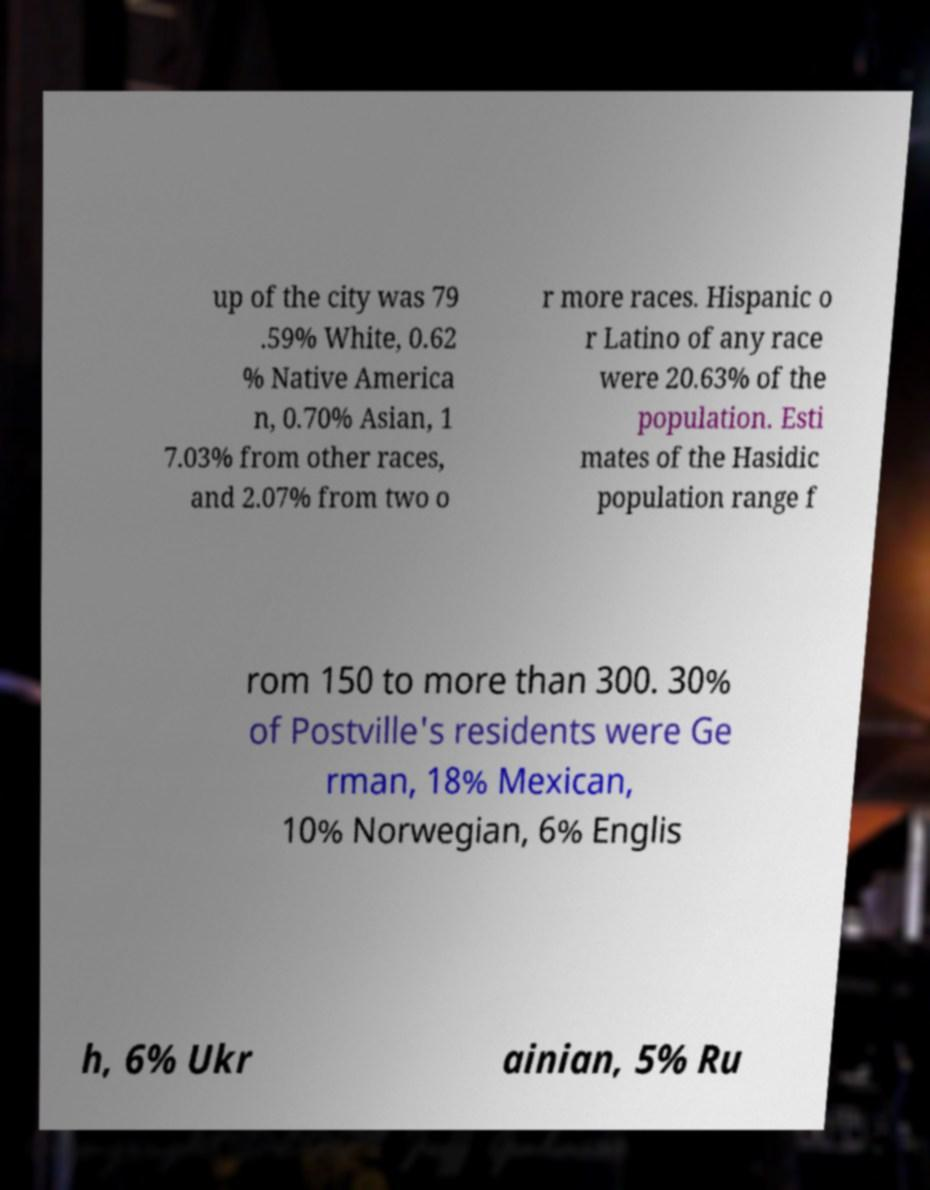Could you extract and type out the text from this image? up of the city was 79 .59% White, 0.62 % Native America n, 0.70% Asian, 1 7.03% from other races, and 2.07% from two o r more races. Hispanic o r Latino of any race were 20.63% of the population. Esti mates of the Hasidic population range f rom 150 to more than 300. 30% of Postville's residents were Ge rman, 18% Mexican, 10% Norwegian, 6% Englis h, 6% Ukr ainian, 5% Ru 